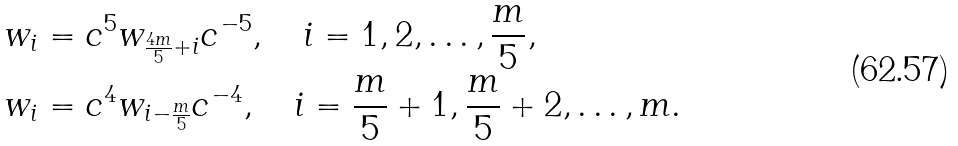<formula> <loc_0><loc_0><loc_500><loc_500>w _ { i } & = c ^ { 5 } w _ { \frac { 4 m } 5 + i } c ^ { - 5 } , \quad i = 1 , 2 , \dots , \frac { m } 5 , \\ w _ { i } & = c ^ { 4 } w _ { i - \frac { m } 5 } c ^ { - 4 } , \quad i = \frac { m } 5 + 1 , \frac { m } 5 + 2 , \dots , m .</formula> 